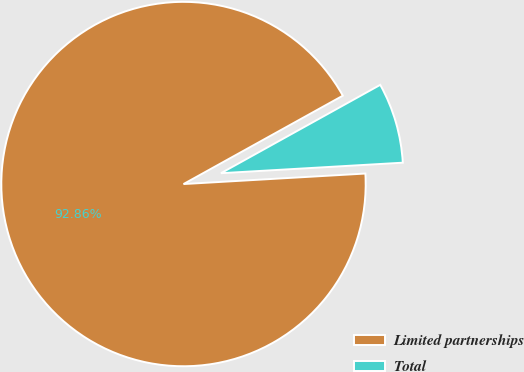<chart> <loc_0><loc_0><loc_500><loc_500><pie_chart><fcel>Limited partnerships<fcel>Total<nl><fcel>92.86%<fcel>7.14%<nl></chart> 